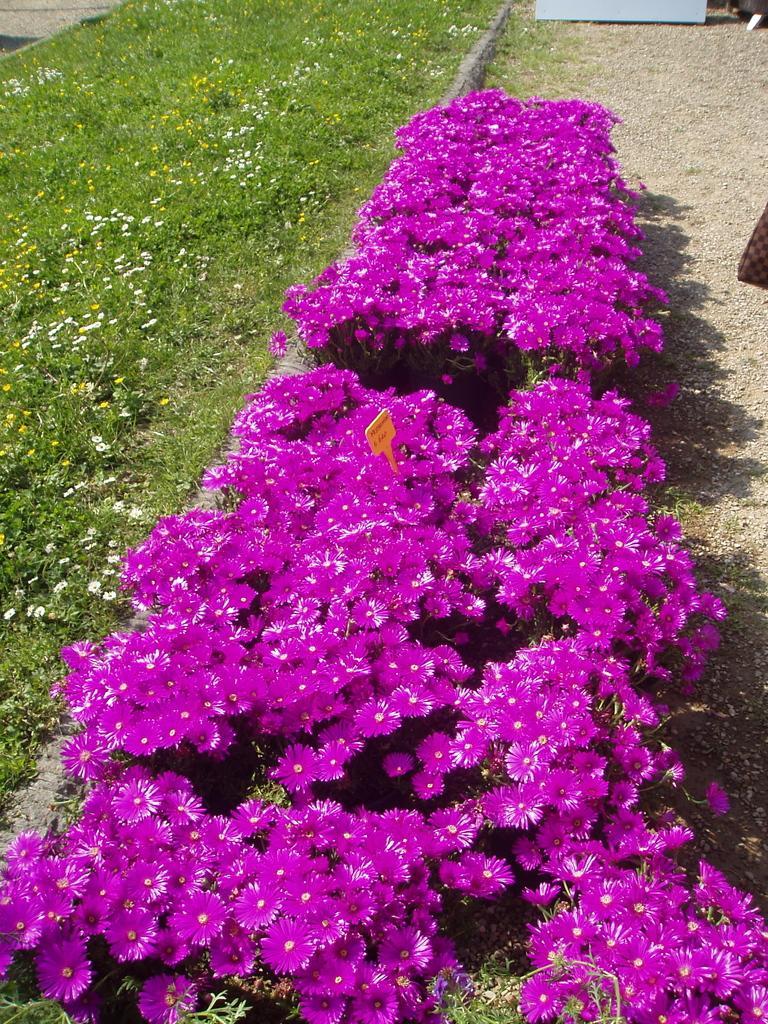In one or two sentences, can you explain what this image depicts? In this image I can see the ground, few flowers which are pink in color, some grass and few other flowers which are yellow and white in color. I can see a yellow colored board in between the pink colored flowers. 